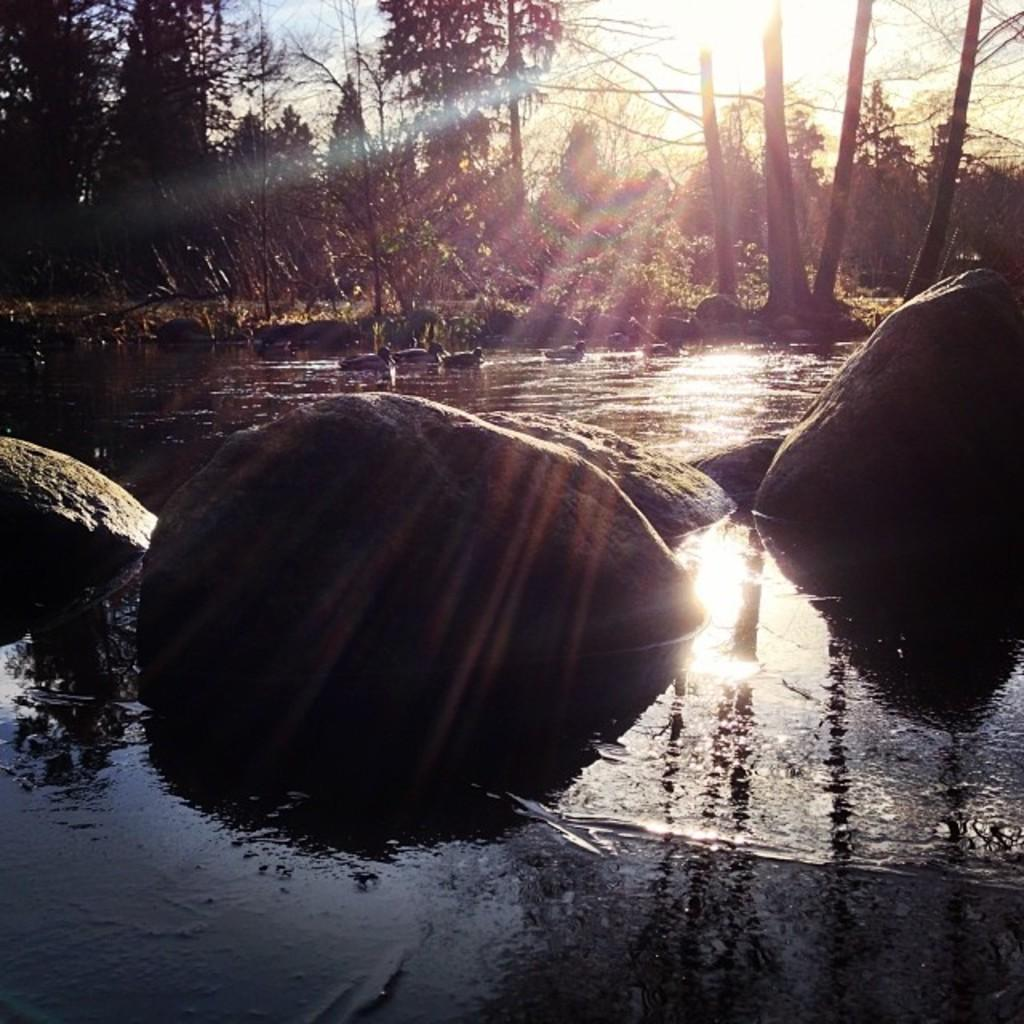What type of natural elements can be seen in the image? There are rocks, water, ducks, trees, plants, and the sky visible in the image. Can you describe the water in the image? The water is visible in the image, but its specific characteristics are not mentioned. What type of animals are in the image? There are ducks in the image. What other natural elements can be seen in the image? There are trees and plants visible in the image. What is visible in the sky in the image? The sun is visible in the sky in the image. What type of dust can be seen covering the rocks in the image? There is no mention of dust in the image, and the rocks do not appear to be covered in any substance. What type of grain is visible in the image? There is no mention of grain in the image. 